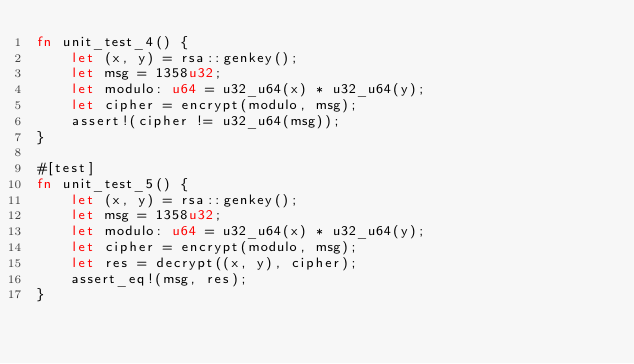Convert code to text. <code><loc_0><loc_0><loc_500><loc_500><_Rust_>fn unit_test_4() {
    let (x, y) = rsa::genkey();
    let msg = 1358u32;
    let modulo: u64 = u32_u64(x) * u32_u64(y);
    let cipher = encrypt(modulo, msg);
    assert!(cipher != u32_u64(msg));
}

#[test]
fn unit_test_5() {
    let (x, y) = rsa::genkey();
    let msg = 1358u32;
    let modulo: u64 = u32_u64(x) * u32_u64(y);
    let cipher = encrypt(modulo, msg);
    let res = decrypt((x, y), cipher);
    assert_eq!(msg, res);
}
</code> 